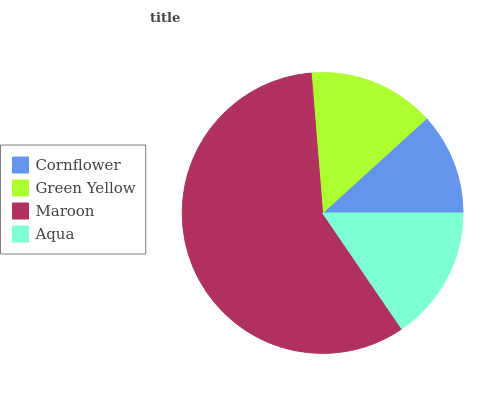Is Cornflower the minimum?
Answer yes or no. Yes. Is Maroon the maximum?
Answer yes or no. Yes. Is Green Yellow the minimum?
Answer yes or no. No. Is Green Yellow the maximum?
Answer yes or no. No. Is Green Yellow greater than Cornflower?
Answer yes or no. Yes. Is Cornflower less than Green Yellow?
Answer yes or no. Yes. Is Cornflower greater than Green Yellow?
Answer yes or no. No. Is Green Yellow less than Cornflower?
Answer yes or no. No. Is Aqua the high median?
Answer yes or no. Yes. Is Green Yellow the low median?
Answer yes or no. Yes. Is Cornflower the high median?
Answer yes or no. No. Is Aqua the low median?
Answer yes or no. No. 